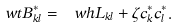<formula> <loc_0><loc_0><loc_500><loc_500>\ w t { B } ^ { * } _ { k l } = \ w h { L } _ { k l } + \zeta c ^ { * } _ { k } c ^ { * } _ { l } .</formula> 